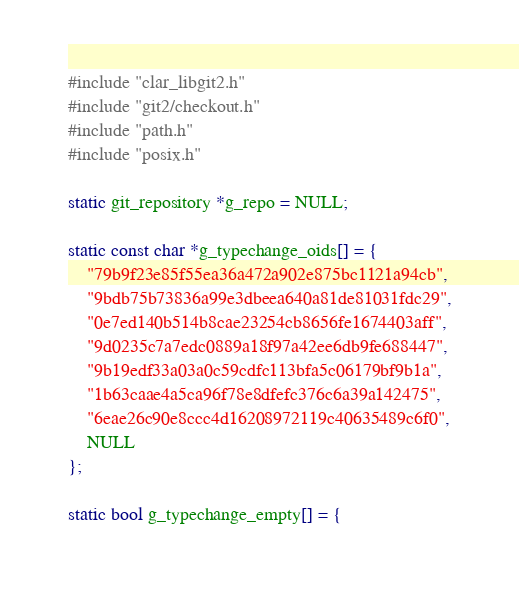<code> <loc_0><loc_0><loc_500><loc_500><_C_>#include "clar_libgit2.h"
#include "git2/checkout.h"
#include "path.h"
#include "posix.h"

static git_repository *g_repo = NULL;

static const char *g_typechange_oids[] = {
	"79b9f23e85f55ea36a472a902e875bc1121a94cb",
	"9bdb75b73836a99e3dbeea640a81de81031fdc29",
	"0e7ed140b514b8cae23254cb8656fe1674403aff",
	"9d0235c7a7edc0889a18f97a42ee6db9fe688447",
	"9b19edf33a03a0c59cdfc113bfa5c06179bf9b1a",
	"1b63caae4a5ca96f78e8dfefc376c6a39a142475",
	"6eae26c90e8ccc4d16208972119c40635489c6f0",
	NULL
};

static bool g_typechange_empty[] = {</code> 